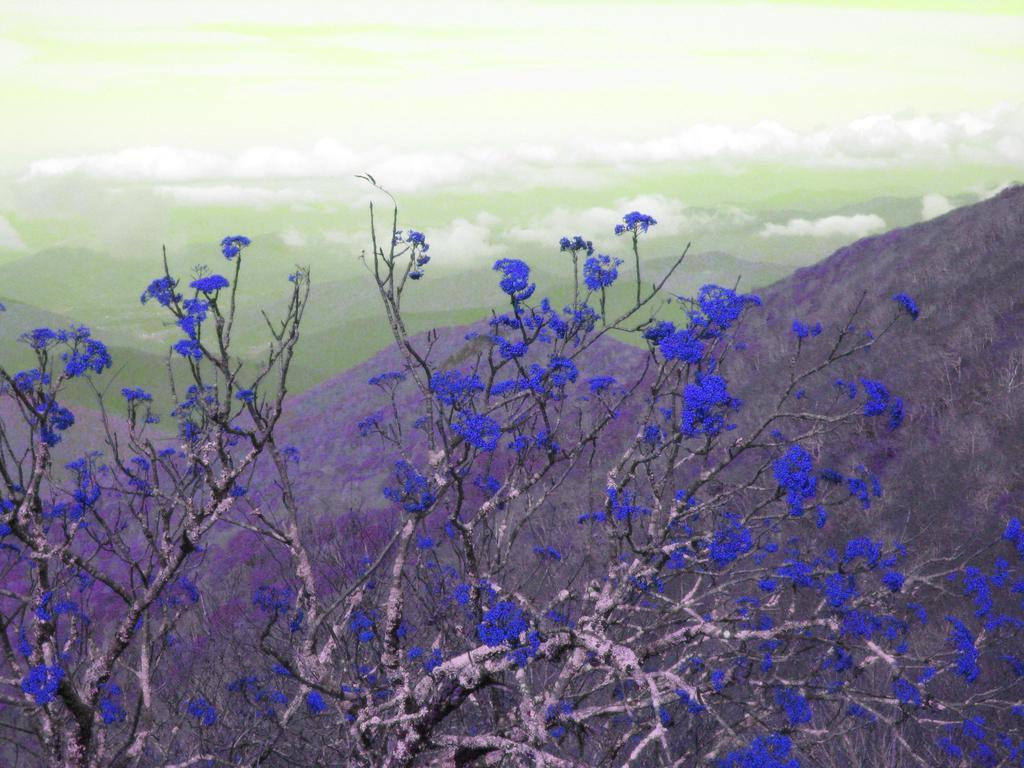In one or two sentences, can you explain what this image depicts? In the image there are purple flowers to a tree and behind there are mountains and above its sky with clouds. 